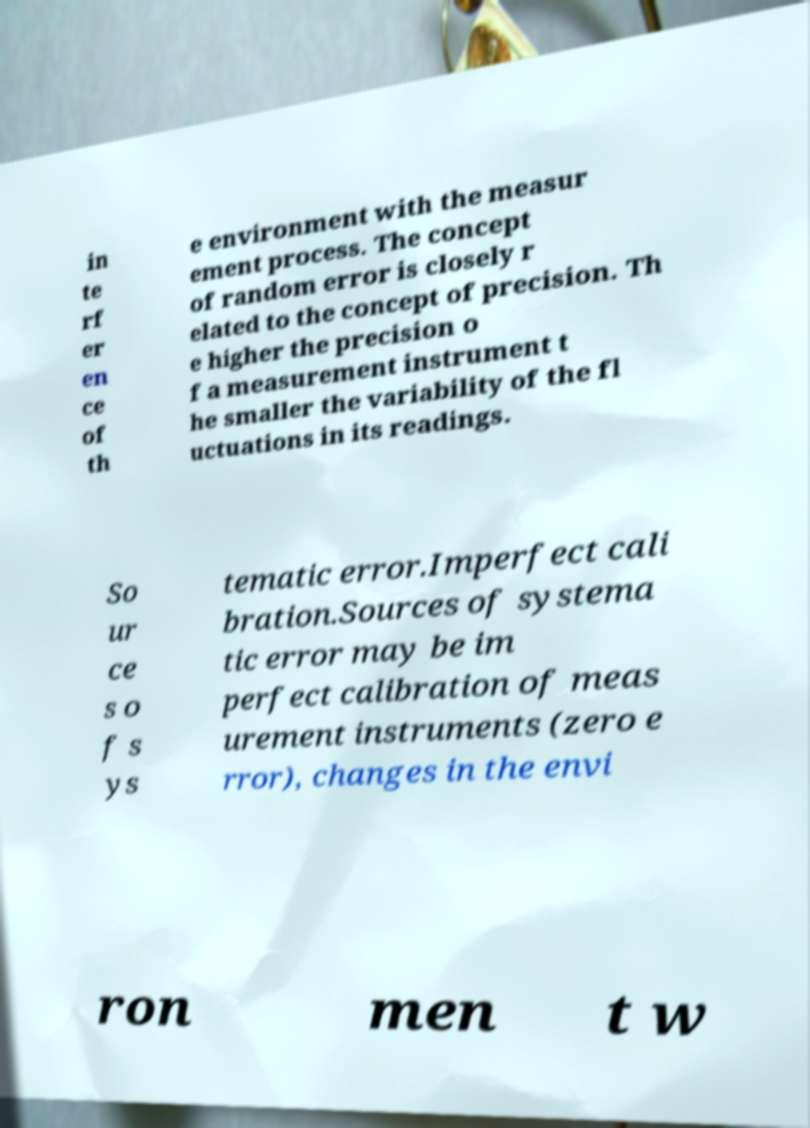Please identify and transcribe the text found in this image. in te rf er en ce of th e environment with the measur ement process. The concept of random error is closely r elated to the concept of precision. Th e higher the precision o f a measurement instrument t he smaller the variability of the fl uctuations in its readings. So ur ce s o f s ys tematic error.Imperfect cali bration.Sources of systema tic error may be im perfect calibration of meas urement instruments (zero e rror), changes in the envi ron men t w 